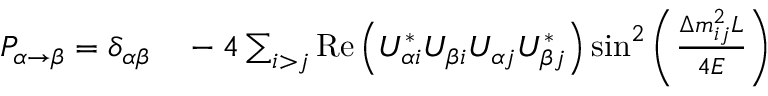<formula> <loc_0><loc_0><loc_500><loc_500>\begin{array} { r l } { P _ { \alpha \rightarrow \beta } = \delta _ { \alpha \beta } } & { } - 4 \sum _ { i > j } { R e } \left ( U _ { \alpha i } ^ { * } U _ { \beta i } U _ { \alpha j } U _ { \beta j } ^ { * } \right ) \sin ^ { 2 } \left ( { \frac { \Delta m _ { i j } ^ { 2 } L } { 4 E } } \right ) } \end{array}</formula> 